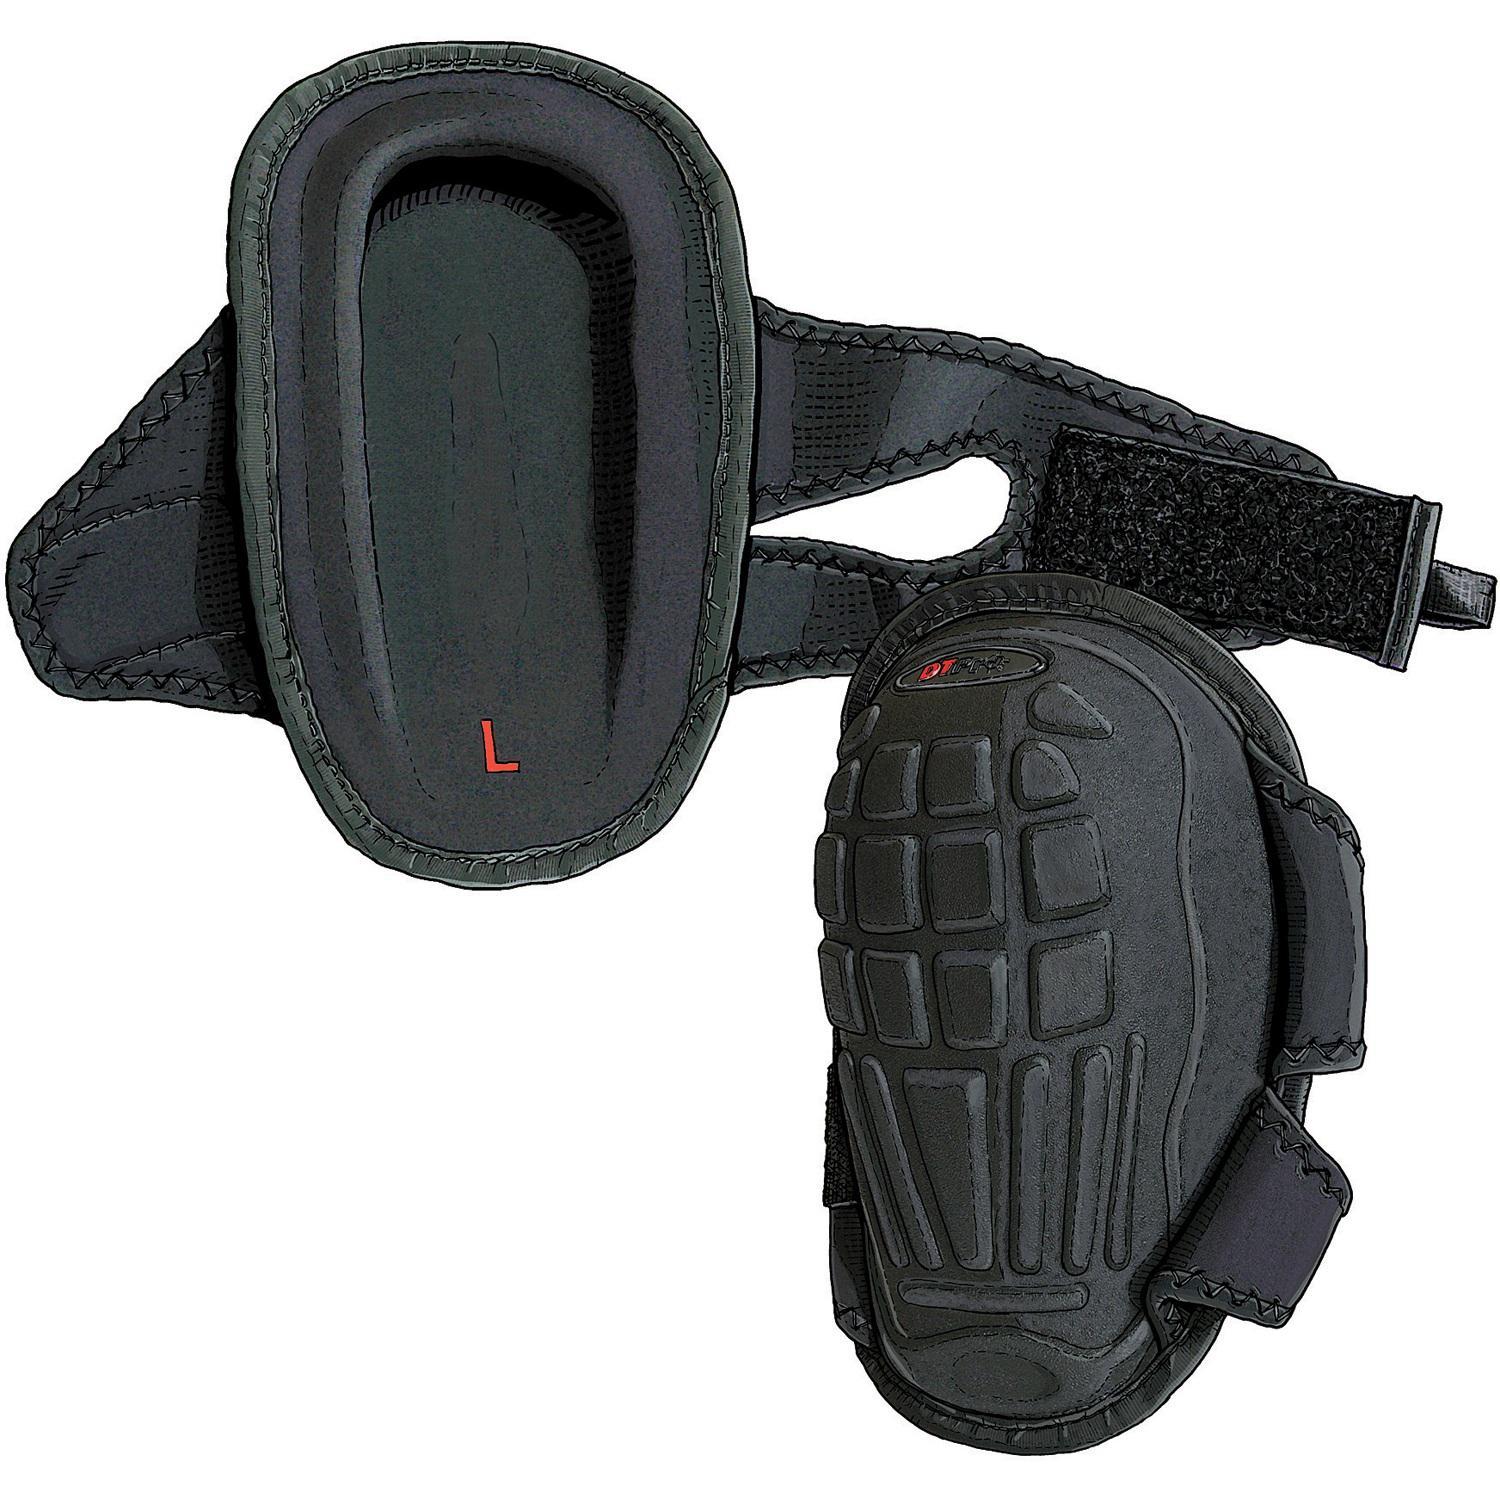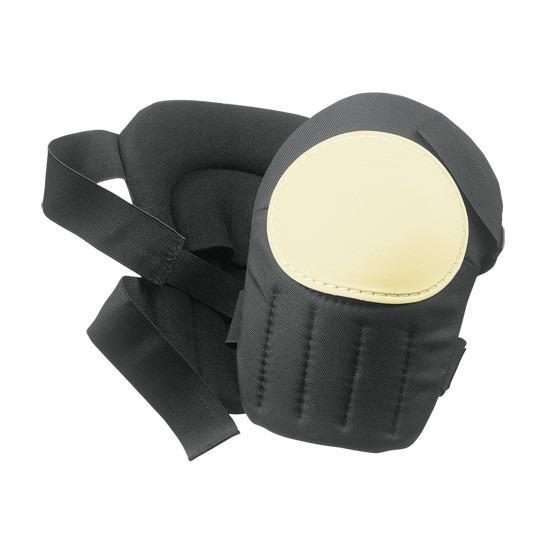The first image is the image on the left, the second image is the image on the right. Examine the images to the left and right. Is the description "The front and back side of one of the pads is visible." accurate? Answer yes or no. Yes. 